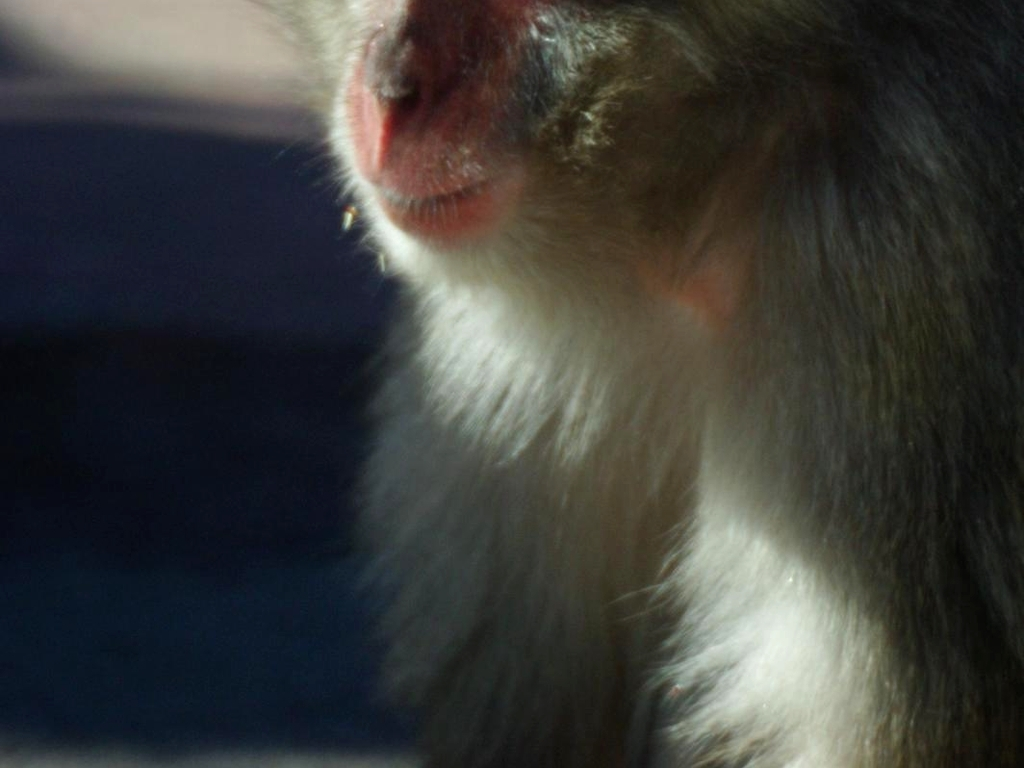What is the condition of the main subject's face?
A. intact
B. incomplete
C. clear
D. detailed
Answer with the option's letter from the given choices directly. A more accurate assessment of the main subject's face in the image would be option A, 'intact.' The image shows a partial view of a subject with fur, and although facial features are obscured by the close-up and lighting, there is no clear evidence of the face being 'incomplete.' 